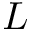<formula> <loc_0><loc_0><loc_500><loc_500>L</formula> 